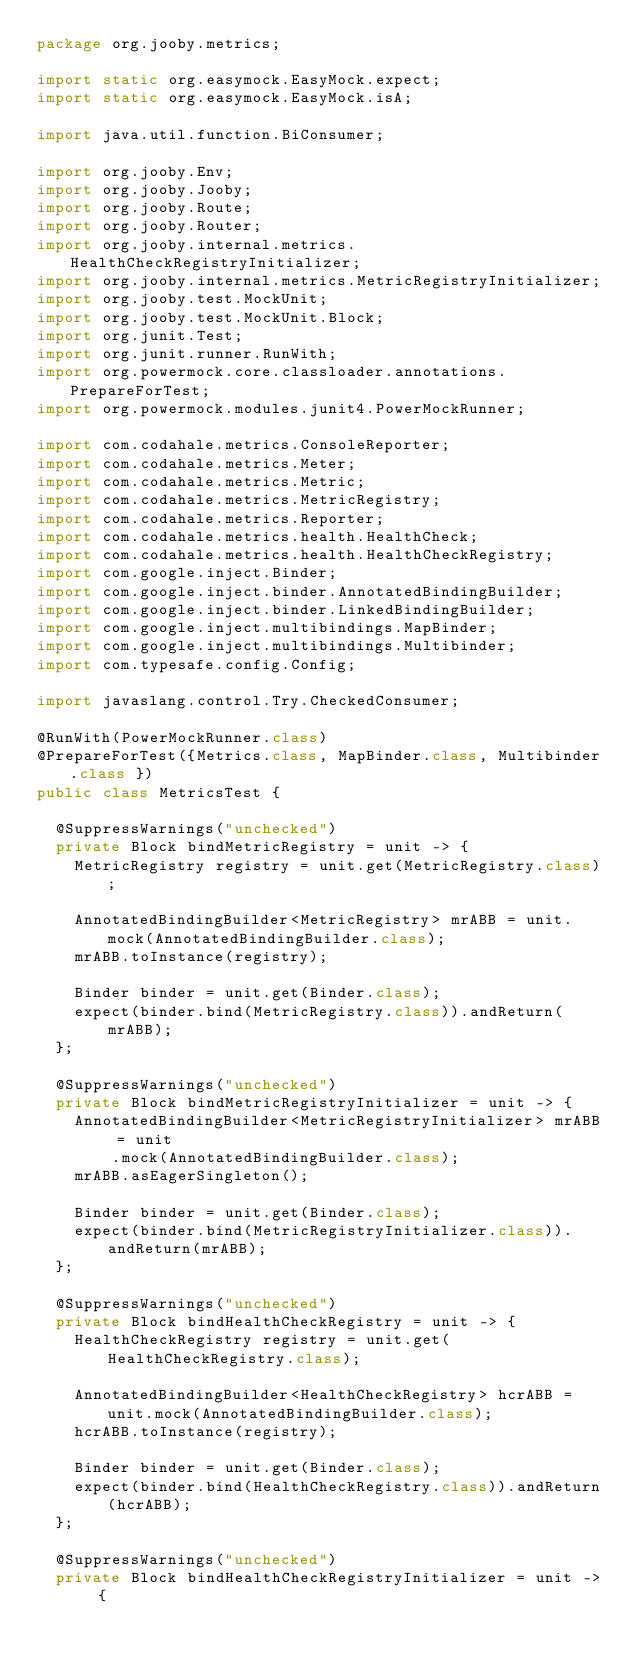Convert code to text. <code><loc_0><loc_0><loc_500><loc_500><_Java_>package org.jooby.metrics;

import static org.easymock.EasyMock.expect;
import static org.easymock.EasyMock.isA;

import java.util.function.BiConsumer;

import org.jooby.Env;
import org.jooby.Jooby;
import org.jooby.Route;
import org.jooby.Router;
import org.jooby.internal.metrics.HealthCheckRegistryInitializer;
import org.jooby.internal.metrics.MetricRegistryInitializer;
import org.jooby.test.MockUnit;
import org.jooby.test.MockUnit.Block;
import org.junit.Test;
import org.junit.runner.RunWith;
import org.powermock.core.classloader.annotations.PrepareForTest;
import org.powermock.modules.junit4.PowerMockRunner;

import com.codahale.metrics.ConsoleReporter;
import com.codahale.metrics.Meter;
import com.codahale.metrics.Metric;
import com.codahale.metrics.MetricRegistry;
import com.codahale.metrics.Reporter;
import com.codahale.metrics.health.HealthCheck;
import com.codahale.metrics.health.HealthCheckRegistry;
import com.google.inject.Binder;
import com.google.inject.binder.AnnotatedBindingBuilder;
import com.google.inject.binder.LinkedBindingBuilder;
import com.google.inject.multibindings.MapBinder;
import com.google.inject.multibindings.Multibinder;
import com.typesafe.config.Config;

import javaslang.control.Try.CheckedConsumer;

@RunWith(PowerMockRunner.class)
@PrepareForTest({Metrics.class, MapBinder.class, Multibinder.class })
public class MetricsTest {

  @SuppressWarnings("unchecked")
  private Block bindMetricRegistry = unit -> {
    MetricRegistry registry = unit.get(MetricRegistry.class);

    AnnotatedBindingBuilder<MetricRegistry> mrABB = unit.mock(AnnotatedBindingBuilder.class);
    mrABB.toInstance(registry);

    Binder binder = unit.get(Binder.class);
    expect(binder.bind(MetricRegistry.class)).andReturn(mrABB);
  };

  @SuppressWarnings("unchecked")
  private Block bindMetricRegistryInitializer = unit -> {
    AnnotatedBindingBuilder<MetricRegistryInitializer> mrABB = unit
        .mock(AnnotatedBindingBuilder.class);
    mrABB.asEagerSingleton();

    Binder binder = unit.get(Binder.class);
    expect(binder.bind(MetricRegistryInitializer.class)).andReturn(mrABB);
  };

  @SuppressWarnings("unchecked")
  private Block bindHealthCheckRegistry = unit -> {
    HealthCheckRegistry registry = unit.get(HealthCheckRegistry.class);

    AnnotatedBindingBuilder<HealthCheckRegistry> hcrABB = unit.mock(AnnotatedBindingBuilder.class);
    hcrABB.toInstance(registry);

    Binder binder = unit.get(Binder.class);
    expect(binder.bind(HealthCheckRegistry.class)).andReturn(hcrABB);
  };

  @SuppressWarnings("unchecked")
  private Block bindHealthCheckRegistryInitializer = unit -> {</code> 